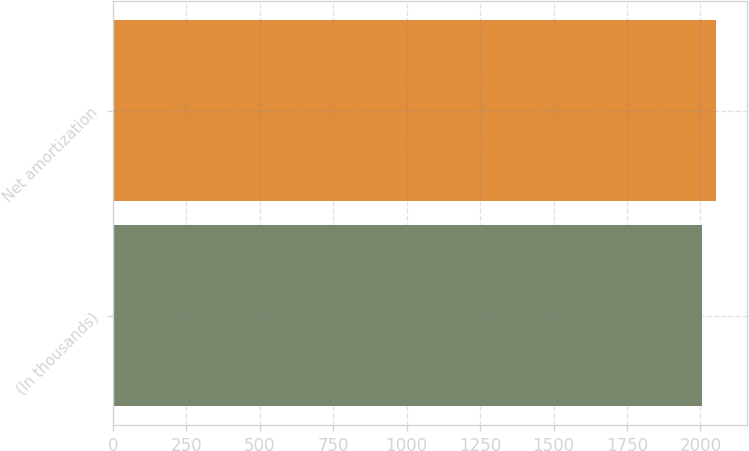<chart> <loc_0><loc_0><loc_500><loc_500><bar_chart><fcel>(In thousands)<fcel>Net amortization<nl><fcel>2004<fcel>2054<nl></chart> 